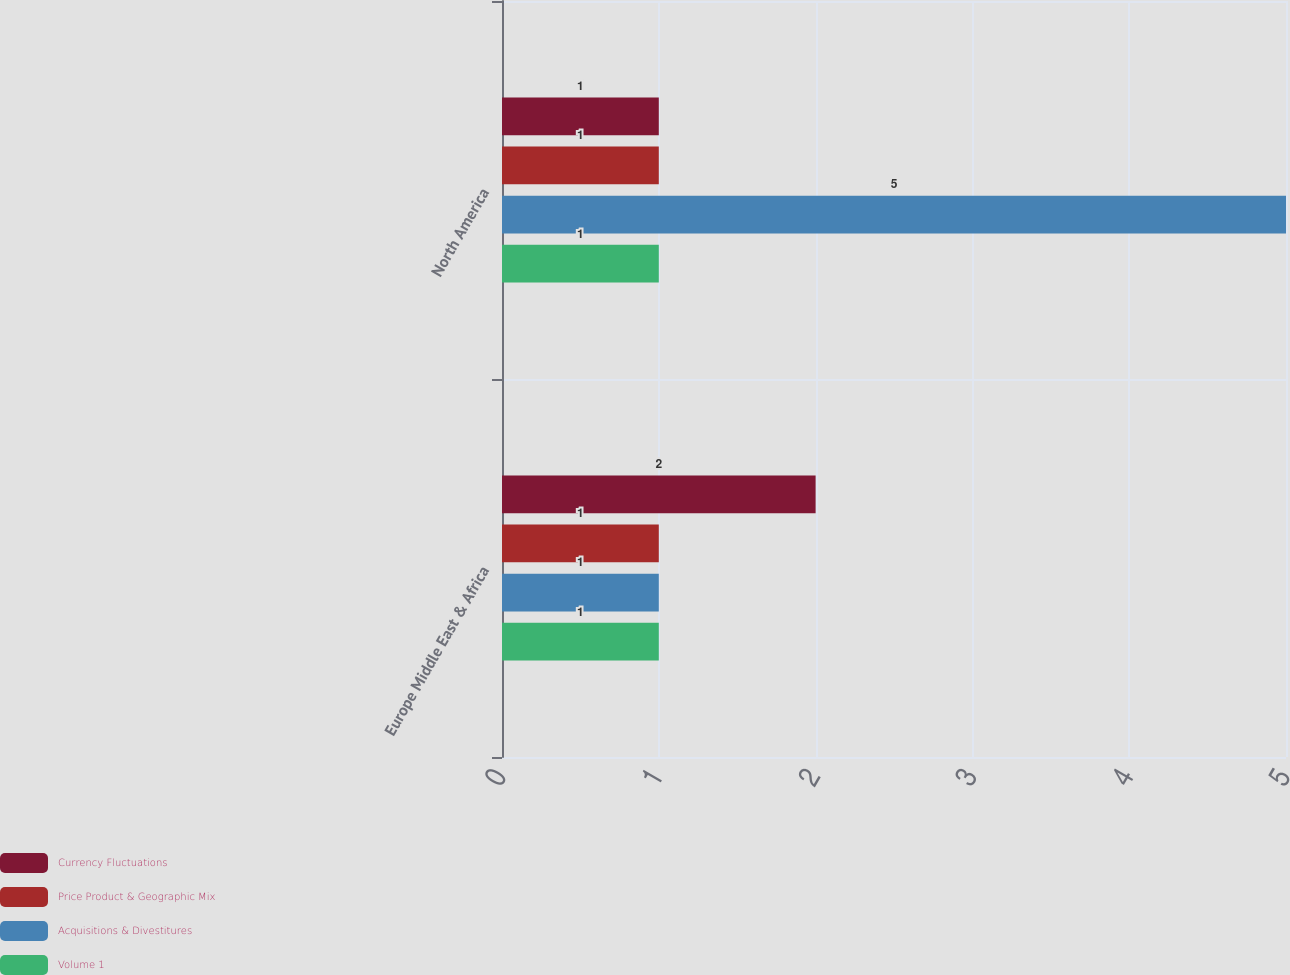Convert chart to OTSL. <chart><loc_0><loc_0><loc_500><loc_500><stacked_bar_chart><ecel><fcel>Europe Middle East & Africa<fcel>North America<nl><fcel>Currency Fluctuations<fcel>2<fcel>1<nl><fcel>Price Product & Geographic Mix<fcel>1<fcel>1<nl><fcel>Acquisitions & Divestitures<fcel>1<fcel>5<nl><fcel>Volume 1<fcel>1<fcel>1<nl></chart> 